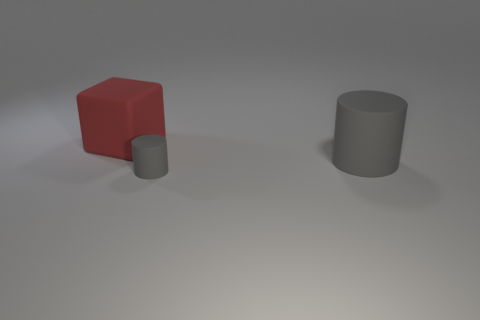Is there anything else that has the same color as the tiny thing?
Your response must be concise. Yes. How many other things are the same size as the matte cube?
Ensure brevity in your answer.  1. The cylinder that is behind the gray cylinder on the left side of the cylinder to the right of the small gray cylinder is made of what material?
Give a very brief answer. Rubber. Are the small thing and the big thing that is on the left side of the big cylinder made of the same material?
Offer a terse response. Yes. Are there fewer red matte objects that are in front of the tiny rubber thing than small gray things that are behind the big red rubber block?
Provide a short and direct response. No. How many other big things have the same material as the red thing?
Your answer should be compact. 1. Are there any large cubes that are to the right of the object in front of the gray thing behind the small thing?
Your answer should be very brief. No. How many cylinders are either blue shiny objects or red matte objects?
Give a very brief answer. 0. There is a small gray thing; does it have the same shape as the big rubber thing that is right of the red matte cube?
Your answer should be compact. Yes. Is the number of big blocks that are to the left of the big red rubber block less than the number of large gray rubber objects?
Your answer should be very brief. Yes. 